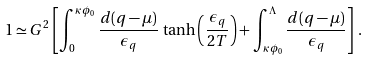Convert formula to latex. <formula><loc_0><loc_0><loc_500><loc_500>1 \simeq G ^ { 2 } \left [ \int _ { 0 } ^ { \kappa \phi _ { 0 } } \frac { d ( q - \mu ) } { \epsilon _ { q } } \, \tanh \left ( \frac { \epsilon _ { q } } { 2 T } \right ) + \int _ { \kappa \phi _ { 0 } } ^ { \Lambda } \frac { d ( q - \mu ) } { \epsilon _ { q } } \right ] \, .</formula> 